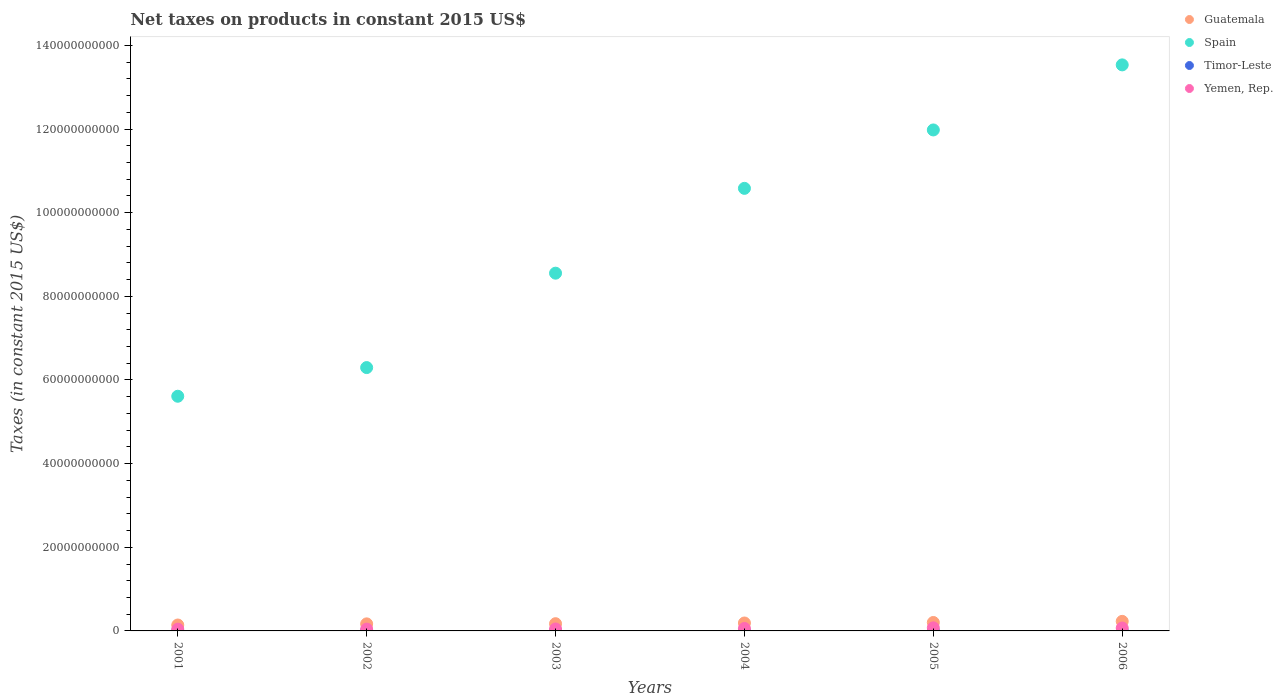How many different coloured dotlines are there?
Offer a very short reply. 4. Is the number of dotlines equal to the number of legend labels?
Keep it short and to the point. No. What is the net taxes on products in Guatemala in 2004?
Your response must be concise. 1.90e+09. Across all years, what is the maximum net taxes on products in Spain?
Your answer should be very brief. 1.35e+11. Across all years, what is the minimum net taxes on products in Spain?
Offer a terse response. 5.61e+1. In which year was the net taxes on products in Timor-Leste maximum?
Offer a very short reply. 2004. What is the total net taxes on products in Guatemala in the graph?
Give a very brief answer. 1.10e+1. What is the difference between the net taxes on products in Yemen, Rep. in 2001 and that in 2003?
Offer a terse response. -4.15e+07. What is the difference between the net taxes on products in Timor-Leste in 2004 and the net taxes on products in Spain in 2002?
Ensure brevity in your answer.  -6.30e+1. What is the average net taxes on products in Spain per year?
Your response must be concise. 9.43e+1. In the year 2005, what is the difference between the net taxes on products in Spain and net taxes on products in Timor-Leste?
Keep it short and to the point. 1.20e+11. In how many years, is the net taxes on products in Spain greater than 92000000000 US$?
Your answer should be compact. 3. What is the ratio of the net taxes on products in Guatemala in 2001 to that in 2002?
Offer a terse response. 0.84. Is the net taxes on products in Yemen, Rep. in 2003 less than that in 2006?
Provide a succinct answer. Yes. Is the difference between the net taxes on products in Spain in 2001 and 2003 greater than the difference between the net taxes on products in Timor-Leste in 2001 and 2003?
Offer a very short reply. No. What is the difference between the highest and the second highest net taxes on products in Spain?
Your response must be concise. 1.56e+1. What is the difference between the highest and the lowest net taxes on products in Yemen, Rep.?
Provide a short and direct response. 3.12e+08. In how many years, is the net taxes on products in Spain greater than the average net taxes on products in Spain taken over all years?
Provide a short and direct response. 3. Is the sum of the net taxes on products in Yemen, Rep. in 2001 and 2004 greater than the maximum net taxes on products in Timor-Leste across all years?
Provide a succinct answer. Yes. Is it the case that in every year, the sum of the net taxes on products in Guatemala and net taxes on products in Timor-Leste  is greater than the sum of net taxes on products in Yemen, Rep. and net taxes on products in Spain?
Keep it short and to the point. Yes. What is the difference between two consecutive major ticks on the Y-axis?
Your response must be concise. 2.00e+1. Are the values on the major ticks of Y-axis written in scientific E-notation?
Give a very brief answer. No. Does the graph contain any zero values?
Provide a short and direct response. Yes. Does the graph contain grids?
Make the answer very short. No. Where does the legend appear in the graph?
Give a very brief answer. Top right. How many legend labels are there?
Provide a short and direct response. 4. What is the title of the graph?
Your answer should be compact. Net taxes on products in constant 2015 US$. Does "Euro area" appear as one of the legend labels in the graph?
Your response must be concise. No. What is the label or title of the Y-axis?
Provide a short and direct response. Taxes (in constant 2015 US$). What is the Taxes (in constant 2015 US$) of Guatemala in 2001?
Ensure brevity in your answer.  1.41e+09. What is the Taxes (in constant 2015 US$) of Spain in 2001?
Make the answer very short. 5.61e+1. What is the Taxes (in constant 2015 US$) in Timor-Leste in 2001?
Keep it short and to the point. 8.00e+06. What is the Taxes (in constant 2015 US$) in Yemen, Rep. in 2001?
Keep it short and to the point. 4.23e+08. What is the Taxes (in constant 2015 US$) of Guatemala in 2002?
Ensure brevity in your answer.  1.69e+09. What is the Taxes (in constant 2015 US$) of Spain in 2002?
Offer a very short reply. 6.30e+1. What is the Taxes (in constant 2015 US$) of Yemen, Rep. in 2002?
Offer a very short reply. 4.32e+08. What is the Taxes (in constant 2015 US$) of Guatemala in 2003?
Offer a terse response. 1.73e+09. What is the Taxes (in constant 2015 US$) in Spain in 2003?
Provide a short and direct response. 8.55e+1. What is the Taxes (in constant 2015 US$) of Timor-Leste in 2003?
Keep it short and to the point. 1.50e+07. What is the Taxes (in constant 2015 US$) in Yemen, Rep. in 2003?
Ensure brevity in your answer.  4.64e+08. What is the Taxes (in constant 2015 US$) in Guatemala in 2004?
Provide a succinct answer. 1.90e+09. What is the Taxes (in constant 2015 US$) of Spain in 2004?
Your response must be concise. 1.06e+11. What is the Taxes (in constant 2015 US$) of Timor-Leste in 2004?
Offer a terse response. 1.60e+07. What is the Taxes (in constant 2015 US$) in Yemen, Rep. in 2004?
Provide a short and direct response. 5.87e+08. What is the Taxes (in constant 2015 US$) in Guatemala in 2005?
Provide a short and direct response. 2.02e+09. What is the Taxes (in constant 2015 US$) in Spain in 2005?
Keep it short and to the point. 1.20e+11. What is the Taxes (in constant 2015 US$) of Timor-Leste in 2005?
Provide a succinct answer. 1.20e+07. What is the Taxes (in constant 2015 US$) in Yemen, Rep. in 2005?
Your answer should be compact. 7.35e+08. What is the Taxes (in constant 2015 US$) of Guatemala in 2006?
Make the answer very short. 2.28e+09. What is the Taxes (in constant 2015 US$) of Spain in 2006?
Provide a succinct answer. 1.35e+11. What is the Taxes (in constant 2015 US$) of Timor-Leste in 2006?
Give a very brief answer. 0. What is the Taxes (in constant 2015 US$) of Yemen, Rep. in 2006?
Make the answer very short. 6.95e+08. Across all years, what is the maximum Taxes (in constant 2015 US$) of Guatemala?
Provide a short and direct response. 2.28e+09. Across all years, what is the maximum Taxes (in constant 2015 US$) of Spain?
Keep it short and to the point. 1.35e+11. Across all years, what is the maximum Taxes (in constant 2015 US$) in Timor-Leste?
Offer a terse response. 1.60e+07. Across all years, what is the maximum Taxes (in constant 2015 US$) in Yemen, Rep.?
Provide a succinct answer. 7.35e+08. Across all years, what is the minimum Taxes (in constant 2015 US$) in Guatemala?
Your response must be concise. 1.41e+09. Across all years, what is the minimum Taxes (in constant 2015 US$) of Spain?
Provide a short and direct response. 5.61e+1. Across all years, what is the minimum Taxes (in constant 2015 US$) in Timor-Leste?
Your response must be concise. 0. Across all years, what is the minimum Taxes (in constant 2015 US$) in Yemen, Rep.?
Provide a short and direct response. 4.23e+08. What is the total Taxes (in constant 2015 US$) in Guatemala in the graph?
Ensure brevity in your answer.  1.10e+1. What is the total Taxes (in constant 2015 US$) of Spain in the graph?
Provide a short and direct response. 5.66e+11. What is the total Taxes (in constant 2015 US$) in Timor-Leste in the graph?
Give a very brief answer. 6.30e+07. What is the total Taxes (in constant 2015 US$) of Yemen, Rep. in the graph?
Offer a very short reply. 3.34e+09. What is the difference between the Taxes (in constant 2015 US$) in Guatemala in 2001 and that in 2002?
Your answer should be compact. -2.72e+08. What is the difference between the Taxes (in constant 2015 US$) of Spain in 2001 and that in 2002?
Provide a succinct answer. -6.86e+09. What is the difference between the Taxes (in constant 2015 US$) of Yemen, Rep. in 2001 and that in 2002?
Ensure brevity in your answer.  -9.52e+06. What is the difference between the Taxes (in constant 2015 US$) in Guatemala in 2001 and that in 2003?
Make the answer very short. -3.14e+08. What is the difference between the Taxes (in constant 2015 US$) of Spain in 2001 and that in 2003?
Offer a very short reply. -2.94e+1. What is the difference between the Taxes (in constant 2015 US$) of Timor-Leste in 2001 and that in 2003?
Provide a succinct answer. -7.00e+06. What is the difference between the Taxes (in constant 2015 US$) of Yemen, Rep. in 2001 and that in 2003?
Provide a succinct answer. -4.15e+07. What is the difference between the Taxes (in constant 2015 US$) in Guatemala in 2001 and that in 2004?
Your response must be concise. -4.82e+08. What is the difference between the Taxes (in constant 2015 US$) of Spain in 2001 and that in 2004?
Offer a terse response. -4.97e+1. What is the difference between the Taxes (in constant 2015 US$) of Timor-Leste in 2001 and that in 2004?
Your answer should be compact. -8.00e+06. What is the difference between the Taxes (in constant 2015 US$) in Yemen, Rep. in 2001 and that in 2004?
Make the answer very short. -1.64e+08. What is the difference between the Taxes (in constant 2015 US$) in Guatemala in 2001 and that in 2005?
Offer a terse response. -6.03e+08. What is the difference between the Taxes (in constant 2015 US$) in Spain in 2001 and that in 2005?
Your answer should be very brief. -6.37e+1. What is the difference between the Taxes (in constant 2015 US$) of Timor-Leste in 2001 and that in 2005?
Provide a short and direct response. -4.00e+06. What is the difference between the Taxes (in constant 2015 US$) of Yemen, Rep. in 2001 and that in 2005?
Ensure brevity in your answer.  -3.12e+08. What is the difference between the Taxes (in constant 2015 US$) of Guatemala in 2001 and that in 2006?
Your response must be concise. -8.70e+08. What is the difference between the Taxes (in constant 2015 US$) of Spain in 2001 and that in 2006?
Your answer should be compact. -7.92e+1. What is the difference between the Taxes (in constant 2015 US$) of Yemen, Rep. in 2001 and that in 2006?
Offer a very short reply. -2.72e+08. What is the difference between the Taxes (in constant 2015 US$) in Guatemala in 2002 and that in 2003?
Your response must be concise. -4.17e+07. What is the difference between the Taxes (in constant 2015 US$) in Spain in 2002 and that in 2003?
Provide a short and direct response. -2.26e+1. What is the difference between the Taxes (in constant 2015 US$) of Timor-Leste in 2002 and that in 2003?
Your answer should be very brief. -3.00e+06. What is the difference between the Taxes (in constant 2015 US$) of Yemen, Rep. in 2002 and that in 2003?
Give a very brief answer. -3.20e+07. What is the difference between the Taxes (in constant 2015 US$) of Guatemala in 2002 and that in 2004?
Keep it short and to the point. -2.09e+08. What is the difference between the Taxes (in constant 2015 US$) of Spain in 2002 and that in 2004?
Provide a short and direct response. -4.29e+1. What is the difference between the Taxes (in constant 2015 US$) of Yemen, Rep. in 2002 and that in 2004?
Provide a succinct answer. -1.54e+08. What is the difference between the Taxes (in constant 2015 US$) in Guatemala in 2002 and that in 2005?
Offer a terse response. -3.30e+08. What is the difference between the Taxes (in constant 2015 US$) of Spain in 2002 and that in 2005?
Provide a short and direct response. -5.68e+1. What is the difference between the Taxes (in constant 2015 US$) of Yemen, Rep. in 2002 and that in 2005?
Offer a very short reply. -3.02e+08. What is the difference between the Taxes (in constant 2015 US$) of Guatemala in 2002 and that in 2006?
Your answer should be compact. -5.98e+08. What is the difference between the Taxes (in constant 2015 US$) of Spain in 2002 and that in 2006?
Your answer should be very brief. -7.24e+1. What is the difference between the Taxes (in constant 2015 US$) in Yemen, Rep. in 2002 and that in 2006?
Offer a very short reply. -2.63e+08. What is the difference between the Taxes (in constant 2015 US$) of Guatemala in 2003 and that in 2004?
Ensure brevity in your answer.  -1.68e+08. What is the difference between the Taxes (in constant 2015 US$) of Spain in 2003 and that in 2004?
Offer a terse response. -2.03e+1. What is the difference between the Taxes (in constant 2015 US$) in Timor-Leste in 2003 and that in 2004?
Make the answer very short. -1.00e+06. What is the difference between the Taxes (in constant 2015 US$) of Yemen, Rep. in 2003 and that in 2004?
Your answer should be compact. -1.22e+08. What is the difference between the Taxes (in constant 2015 US$) of Guatemala in 2003 and that in 2005?
Provide a succinct answer. -2.89e+08. What is the difference between the Taxes (in constant 2015 US$) in Spain in 2003 and that in 2005?
Your answer should be very brief. -3.42e+1. What is the difference between the Taxes (in constant 2015 US$) of Timor-Leste in 2003 and that in 2005?
Make the answer very short. 3.00e+06. What is the difference between the Taxes (in constant 2015 US$) in Yemen, Rep. in 2003 and that in 2005?
Provide a succinct answer. -2.70e+08. What is the difference between the Taxes (in constant 2015 US$) of Guatemala in 2003 and that in 2006?
Your answer should be compact. -5.57e+08. What is the difference between the Taxes (in constant 2015 US$) of Spain in 2003 and that in 2006?
Offer a very short reply. -4.98e+1. What is the difference between the Taxes (in constant 2015 US$) of Yemen, Rep. in 2003 and that in 2006?
Make the answer very short. -2.31e+08. What is the difference between the Taxes (in constant 2015 US$) in Guatemala in 2004 and that in 2005?
Offer a very short reply. -1.21e+08. What is the difference between the Taxes (in constant 2015 US$) in Spain in 2004 and that in 2005?
Ensure brevity in your answer.  -1.40e+1. What is the difference between the Taxes (in constant 2015 US$) of Yemen, Rep. in 2004 and that in 2005?
Offer a terse response. -1.48e+08. What is the difference between the Taxes (in constant 2015 US$) of Guatemala in 2004 and that in 2006?
Keep it short and to the point. -3.89e+08. What is the difference between the Taxes (in constant 2015 US$) of Spain in 2004 and that in 2006?
Offer a very short reply. -2.95e+1. What is the difference between the Taxes (in constant 2015 US$) of Yemen, Rep. in 2004 and that in 2006?
Ensure brevity in your answer.  -1.09e+08. What is the difference between the Taxes (in constant 2015 US$) of Guatemala in 2005 and that in 2006?
Make the answer very short. -2.68e+08. What is the difference between the Taxes (in constant 2015 US$) of Spain in 2005 and that in 2006?
Give a very brief answer. -1.56e+1. What is the difference between the Taxes (in constant 2015 US$) of Yemen, Rep. in 2005 and that in 2006?
Your answer should be very brief. 3.95e+07. What is the difference between the Taxes (in constant 2015 US$) in Guatemala in 2001 and the Taxes (in constant 2015 US$) in Spain in 2002?
Your answer should be very brief. -6.16e+1. What is the difference between the Taxes (in constant 2015 US$) in Guatemala in 2001 and the Taxes (in constant 2015 US$) in Timor-Leste in 2002?
Make the answer very short. 1.40e+09. What is the difference between the Taxes (in constant 2015 US$) of Guatemala in 2001 and the Taxes (in constant 2015 US$) of Yemen, Rep. in 2002?
Make the answer very short. 9.81e+08. What is the difference between the Taxes (in constant 2015 US$) in Spain in 2001 and the Taxes (in constant 2015 US$) in Timor-Leste in 2002?
Provide a short and direct response. 5.61e+1. What is the difference between the Taxes (in constant 2015 US$) in Spain in 2001 and the Taxes (in constant 2015 US$) in Yemen, Rep. in 2002?
Give a very brief answer. 5.57e+1. What is the difference between the Taxes (in constant 2015 US$) of Timor-Leste in 2001 and the Taxes (in constant 2015 US$) of Yemen, Rep. in 2002?
Keep it short and to the point. -4.24e+08. What is the difference between the Taxes (in constant 2015 US$) of Guatemala in 2001 and the Taxes (in constant 2015 US$) of Spain in 2003?
Make the answer very short. -8.41e+1. What is the difference between the Taxes (in constant 2015 US$) of Guatemala in 2001 and the Taxes (in constant 2015 US$) of Timor-Leste in 2003?
Ensure brevity in your answer.  1.40e+09. What is the difference between the Taxes (in constant 2015 US$) in Guatemala in 2001 and the Taxes (in constant 2015 US$) in Yemen, Rep. in 2003?
Your answer should be compact. 9.49e+08. What is the difference between the Taxes (in constant 2015 US$) in Spain in 2001 and the Taxes (in constant 2015 US$) in Timor-Leste in 2003?
Provide a succinct answer. 5.61e+1. What is the difference between the Taxes (in constant 2015 US$) of Spain in 2001 and the Taxes (in constant 2015 US$) of Yemen, Rep. in 2003?
Ensure brevity in your answer.  5.56e+1. What is the difference between the Taxes (in constant 2015 US$) in Timor-Leste in 2001 and the Taxes (in constant 2015 US$) in Yemen, Rep. in 2003?
Offer a very short reply. -4.56e+08. What is the difference between the Taxes (in constant 2015 US$) in Guatemala in 2001 and the Taxes (in constant 2015 US$) in Spain in 2004?
Offer a very short reply. -1.04e+11. What is the difference between the Taxes (in constant 2015 US$) in Guatemala in 2001 and the Taxes (in constant 2015 US$) in Timor-Leste in 2004?
Make the answer very short. 1.40e+09. What is the difference between the Taxes (in constant 2015 US$) of Guatemala in 2001 and the Taxes (in constant 2015 US$) of Yemen, Rep. in 2004?
Keep it short and to the point. 8.27e+08. What is the difference between the Taxes (in constant 2015 US$) of Spain in 2001 and the Taxes (in constant 2015 US$) of Timor-Leste in 2004?
Ensure brevity in your answer.  5.61e+1. What is the difference between the Taxes (in constant 2015 US$) of Spain in 2001 and the Taxes (in constant 2015 US$) of Yemen, Rep. in 2004?
Make the answer very short. 5.55e+1. What is the difference between the Taxes (in constant 2015 US$) in Timor-Leste in 2001 and the Taxes (in constant 2015 US$) in Yemen, Rep. in 2004?
Provide a succinct answer. -5.79e+08. What is the difference between the Taxes (in constant 2015 US$) in Guatemala in 2001 and the Taxes (in constant 2015 US$) in Spain in 2005?
Offer a very short reply. -1.18e+11. What is the difference between the Taxes (in constant 2015 US$) in Guatemala in 2001 and the Taxes (in constant 2015 US$) in Timor-Leste in 2005?
Your response must be concise. 1.40e+09. What is the difference between the Taxes (in constant 2015 US$) in Guatemala in 2001 and the Taxes (in constant 2015 US$) in Yemen, Rep. in 2005?
Provide a succinct answer. 6.79e+08. What is the difference between the Taxes (in constant 2015 US$) in Spain in 2001 and the Taxes (in constant 2015 US$) in Timor-Leste in 2005?
Your answer should be very brief. 5.61e+1. What is the difference between the Taxes (in constant 2015 US$) in Spain in 2001 and the Taxes (in constant 2015 US$) in Yemen, Rep. in 2005?
Give a very brief answer. 5.54e+1. What is the difference between the Taxes (in constant 2015 US$) of Timor-Leste in 2001 and the Taxes (in constant 2015 US$) of Yemen, Rep. in 2005?
Give a very brief answer. -7.27e+08. What is the difference between the Taxes (in constant 2015 US$) in Guatemala in 2001 and the Taxes (in constant 2015 US$) in Spain in 2006?
Offer a terse response. -1.34e+11. What is the difference between the Taxes (in constant 2015 US$) of Guatemala in 2001 and the Taxes (in constant 2015 US$) of Yemen, Rep. in 2006?
Keep it short and to the point. 7.18e+08. What is the difference between the Taxes (in constant 2015 US$) in Spain in 2001 and the Taxes (in constant 2015 US$) in Yemen, Rep. in 2006?
Give a very brief answer. 5.54e+1. What is the difference between the Taxes (in constant 2015 US$) in Timor-Leste in 2001 and the Taxes (in constant 2015 US$) in Yemen, Rep. in 2006?
Make the answer very short. -6.87e+08. What is the difference between the Taxes (in constant 2015 US$) of Guatemala in 2002 and the Taxes (in constant 2015 US$) of Spain in 2003?
Keep it short and to the point. -8.39e+1. What is the difference between the Taxes (in constant 2015 US$) in Guatemala in 2002 and the Taxes (in constant 2015 US$) in Timor-Leste in 2003?
Your response must be concise. 1.67e+09. What is the difference between the Taxes (in constant 2015 US$) of Guatemala in 2002 and the Taxes (in constant 2015 US$) of Yemen, Rep. in 2003?
Provide a succinct answer. 1.22e+09. What is the difference between the Taxes (in constant 2015 US$) in Spain in 2002 and the Taxes (in constant 2015 US$) in Timor-Leste in 2003?
Ensure brevity in your answer.  6.30e+1. What is the difference between the Taxes (in constant 2015 US$) in Spain in 2002 and the Taxes (in constant 2015 US$) in Yemen, Rep. in 2003?
Make the answer very short. 6.25e+1. What is the difference between the Taxes (in constant 2015 US$) in Timor-Leste in 2002 and the Taxes (in constant 2015 US$) in Yemen, Rep. in 2003?
Give a very brief answer. -4.52e+08. What is the difference between the Taxes (in constant 2015 US$) in Guatemala in 2002 and the Taxes (in constant 2015 US$) in Spain in 2004?
Provide a succinct answer. -1.04e+11. What is the difference between the Taxes (in constant 2015 US$) in Guatemala in 2002 and the Taxes (in constant 2015 US$) in Timor-Leste in 2004?
Make the answer very short. 1.67e+09. What is the difference between the Taxes (in constant 2015 US$) of Guatemala in 2002 and the Taxes (in constant 2015 US$) of Yemen, Rep. in 2004?
Give a very brief answer. 1.10e+09. What is the difference between the Taxes (in constant 2015 US$) in Spain in 2002 and the Taxes (in constant 2015 US$) in Timor-Leste in 2004?
Ensure brevity in your answer.  6.30e+1. What is the difference between the Taxes (in constant 2015 US$) in Spain in 2002 and the Taxes (in constant 2015 US$) in Yemen, Rep. in 2004?
Your response must be concise. 6.24e+1. What is the difference between the Taxes (in constant 2015 US$) of Timor-Leste in 2002 and the Taxes (in constant 2015 US$) of Yemen, Rep. in 2004?
Provide a succinct answer. -5.75e+08. What is the difference between the Taxes (in constant 2015 US$) of Guatemala in 2002 and the Taxes (in constant 2015 US$) of Spain in 2005?
Offer a terse response. -1.18e+11. What is the difference between the Taxes (in constant 2015 US$) in Guatemala in 2002 and the Taxes (in constant 2015 US$) in Timor-Leste in 2005?
Your answer should be very brief. 1.67e+09. What is the difference between the Taxes (in constant 2015 US$) of Guatemala in 2002 and the Taxes (in constant 2015 US$) of Yemen, Rep. in 2005?
Make the answer very short. 9.51e+08. What is the difference between the Taxes (in constant 2015 US$) of Spain in 2002 and the Taxes (in constant 2015 US$) of Timor-Leste in 2005?
Provide a short and direct response. 6.30e+1. What is the difference between the Taxes (in constant 2015 US$) of Spain in 2002 and the Taxes (in constant 2015 US$) of Yemen, Rep. in 2005?
Your answer should be compact. 6.22e+1. What is the difference between the Taxes (in constant 2015 US$) in Timor-Leste in 2002 and the Taxes (in constant 2015 US$) in Yemen, Rep. in 2005?
Provide a succinct answer. -7.23e+08. What is the difference between the Taxes (in constant 2015 US$) in Guatemala in 2002 and the Taxes (in constant 2015 US$) in Spain in 2006?
Make the answer very short. -1.34e+11. What is the difference between the Taxes (in constant 2015 US$) in Guatemala in 2002 and the Taxes (in constant 2015 US$) in Yemen, Rep. in 2006?
Make the answer very short. 9.90e+08. What is the difference between the Taxes (in constant 2015 US$) of Spain in 2002 and the Taxes (in constant 2015 US$) of Yemen, Rep. in 2006?
Provide a short and direct response. 6.23e+1. What is the difference between the Taxes (in constant 2015 US$) of Timor-Leste in 2002 and the Taxes (in constant 2015 US$) of Yemen, Rep. in 2006?
Keep it short and to the point. -6.83e+08. What is the difference between the Taxes (in constant 2015 US$) of Guatemala in 2003 and the Taxes (in constant 2015 US$) of Spain in 2004?
Give a very brief answer. -1.04e+11. What is the difference between the Taxes (in constant 2015 US$) in Guatemala in 2003 and the Taxes (in constant 2015 US$) in Timor-Leste in 2004?
Provide a succinct answer. 1.71e+09. What is the difference between the Taxes (in constant 2015 US$) in Guatemala in 2003 and the Taxes (in constant 2015 US$) in Yemen, Rep. in 2004?
Make the answer very short. 1.14e+09. What is the difference between the Taxes (in constant 2015 US$) in Spain in 2003 and the Taxes (in constant 2015 US$) in Timor-Leste in 2004?
Make the answer very short. 8.55e+1. What is the difference between the Taxes (in constant 2015 US$) in Spain in 2003 and the Taxes (in constant 2015 US$) in Yemen, Rep. in 2004?
Give a very brief answer. 8.50e+1. What is the difference between the Taxes (in constant 2015 US$) in Timor-Leste in 2003 and the Taxes (in constant 2015 US$) in Yemen, Rep. in 2004?
Your answer should be compact. -5.72e+08. What is the difference between the Taxes (in constant 2015 US$) in Guatemala in 2003 and the Taxes (in constant 2015 US$) in Spain in 2005?
Provide a succinct answer. -1.18e+11. What is the difference between the Taxes (in constant 2015 US$) in Guatemala in 2003 and the Taxes (in constant 2015 US$) in Timor-Leste in 2005?
Offer a terse response. 1.72e+09. What is the difference between the Taxes (in constant 2015 US$) in Guatemala in 2003 and the Taxes (in constant 2015 US$) in Yemen, Rep. in 2005?
Your response must be concise. 9.93e+08. What is the difference between the Taxes (in constant 2015 US$) in Spain in 2003 and the Taxes (in constant 2015 US$) in Timor-Leste in 2005?
Offer a very short reply. 8.55e+1. What is the difference between the Taxes (in constant 2015 US$) in Spain in 2003 and the Taxes (in constant 2015 US$) in Yemen, Rep. in 2005?
Offer a very short reply. 8.48e+1. What is the difference between the Taxes (in constant 2015 US$) in Timor-Leste in 2003 and the Taxes (in constant 2015 US$) in Yemen, Rep. in 2005?
Offer a very short reply. -7.20e+08. What is the difference between the Taxes (in constant 2015 US$) of Guatemala in 2003 and the Taxes (in constant 2015 US$) of Spain in 2006?
Provide a short and direct response. -1.34e+11. What is the difference between the Taxes (in constant 2015 US$) in Guatemala in 2003 and the Taxes (in constant 2015 US$) in Yemen, Rep. in 2006?
Make the answer very short. 1.03e+09. What is the difference between the Taxes (in constant 2015 US$) of Spain in 2003 and the Taxes (in constant 2015 US$) of Yemen, Rep. in 2006?
Your response must be concise. 8.48e+1. What is the difference between the Taxes (in constant 2015 US$) in Timor-Leste in 2003 and the Taxes (in constant 2015 US$) in Yemen, Rep. in 2006?
Make the answer very short. -6.80e+08. What is the difference between the Taxes (in constant 2015 US$) of Guatemala in 2004 and the Taxes (in constant 2015 US$) of Spain in 2005?
Provide a succinct answer. -1.18e+11. What is the difference between the Taxes (in constant 2015 US$) of Guatemala in 2004 and the Taxes (in constant 2015 US$) of Timor-Leste in 2005?
Give a very brief answer. 1.88e+09. What is the difference between the Taxes (in constant 2015 US$) in Guatemala in 2004 and the Taxes (in constant 2015 US$) in Yemen, Rep. in 2005?
Keep it short and to the point. 1.16e+09. What is the difference between the Taxes (in constant 2015 US$) in Spain in 2004 and the Taxes (in constant 2015 US$) in Timor-Leste in 2005?
Make the answer very short. 1.06e+11. What is the difference between the Taxes (in constant 2015 US$) of Spain in 2004 and the Taxes (in constant 2015 US$) of Yemen, Rep. in 2005?
Your answer should be compact. 1.05e+11. What is the difference between the Taxes (in constant 2015 US$) in Timor-Leste in 2004 and the Taxes (in constant 2015 US$) in Yemen, Rep. in 2005?
Give a very brief answer. -7.19e+08. What is the difference between the Taxes (in constant 2015 US$) of Guatemala in 2004 and the Taxes (in constant 2015 US$) of Spain in 2006?
Give a very brief answer. -1.33e+11. What is the difference between the Taxes (in constant 2015 US$) in Guatemala in 2004 and the Taxes (in constant 2015 US$) in Yemen, Rep. in 2006?
Ensure brevity in your answer.  1.20e+09. What is the difference between the Taxes (in constant 2015 US$) of Spain in 2004 and the Taxes (in constant 2015 US$) of Yemen, Rep. in 2006?
Offer a very short reply. 1.05e+11. What is the difference between the Taxes (in constant 2015 US$) of Timor-Leste in 2004 and the Taxes (in constant 2015 US$) of Yemen, Rep. in 2006?
Provide a short and direct response. -6.79e+08. What is the difference between the Taxes (in constant 2015 US$) of Guatemala in 2005 and the Taxes (in constant 2015 US$) of Spain in 2006?
Offer a very short reply. -1.33e+11. What is the difference between the Taxes (in constant 2015 US$) in Guatemala in 2005 and the Taxes (in constant 2015 US$) in Yemen, Rep. in 2006?
Give a very brief answer. 1.32e+09. What is the difference between the Taxes (in constant 2015 US$) in Spain in 2005 and the Taxes (in constant 2015 US$) in Yemen, Rep. in 2006?
Offer a very short reply. 1.19e+11. What is the difference between the Taxes (in constant 2015 US$) of Timor-Leste in 2005 and the Taxes (in constant 2015 US$) of Yemen, Rep. in 2006?
Offer a very short reply. -6.83e+08. What is the average Taxes (in constant 2015 US$) of Guatemala per year?
Your answer should be very brief. 1.84e+09. What is the average Taxes (in constant 2015 US$) in Spain per year?
Make the answer very short. 9.43e+1. What is the average Taxes (in constant 2015 US$) in Timor-Leste per year?
Keep it short and to the point. 1.05e+07. What is the average Taxes (in constant 2015 US$) in Yemen, Rep. per year?
Your answer should be very brief. 5.56e+08. In the year 2001, what is the difference between the Taxes (in constant 2015 US$) of Guatemala and Taxes (in constant 2015 US$) of Spain?
Provide a short and direct response. -5.47e+1. In the year 2001, what is the difference between the Taxes (in constant 2015 US$) in Guatemala and Taxes (in constant 2015 US$) in Timor-Leste?
Offer a very short reply. 1.41e+09. In the year 2001, what is the difference between the Taxes (in constant 2015 US$) in Guatemala and Taxes (in constant 2015 US$) in Yemen, Rep.?
Make the answer very short. 9.91e+08. In the year 2001, what is the difference between the Taxes (in constant 2015 US$) of Spain and Taxes (in constant 2015 US$) of Timor-Leste?
Give a very brief answer. 5.61e+1. In the year 2001, what is the difference between the Taxes (in constant 2015 US$) in Spain and Taxes (in constant 2015 US$) in Yemen, Rep.?
Provide a succinct answer. 5.57e+1. In the year 2001, what is the difference between the Taxes (in constant 2015 US$) of Timor-Leste and Taxes (in constant 2015 US$) of Yemen, Rep.?
Your answer should be compact. -4.15e+08. In the year 2002, what is the difference between the Taxes (in constant 2015 US$) in Guatemala and Taxes (in constant 2015 US$) in Spain?
Offer a terse response. -6.13e+1. In the year 2002, what is the difference between the Taxes (in constant 2015 US$) of Guatemala and Taxes (in constant 2015 US$) of Timor-Leste?
Make the answer very short. 1.67e+09. In the year 2002, what is the difference between the Taxes (in constant 2015 US$) of Guatemala and Taxes (in constant 2015 US$) of Yemen, Rep.?
Keep it short and to the point. 1.25e+09. In the year 2002, what is the difference between the Taxes (in constant 2015 US$) in Spain and Taxes (in constant 2015 US$) in Timor-Leste?
Your answer should be very brief. 6.30e+1. In the year 2002, what is the difference between the Taxes (in constant 2015 US$) of Spain and Taxes (in constant 2015 US$) of Yemen, Rep.?
Provide a succinct answer. 6.25e+1. In the year 2002, what is the difference between the Taxes (in constant 2015 US$) of Timor-Leste and Taxes (in constant 2015 US$) of Yemen, Rep.?
Offer a terse response. -4.20e+08. In the year 2003, what is the difference between the Taxes (in constant 2015 US$) of Guatemala and Taxes (in constant 2015 US$) of Spain?
Provide a succinct answer. -8.38e+1. In the year 2003, what is the difference between the Taxes (in constant 2015 US$) of Guatemala and Taxes (in constant 2015 US$) of Timor-Leste?
Keep it short and to the point. 1.71e+09. In the year 2003, what is the difference between the Taxes (in constant 2015 US$) of Guatemala and Taxes (in constant 2015 US$) of Yemen, Rep.?
Provide a short and direct response. 1.26e+09. In the year 2003, what is the difference between the Taxes (in constant 2015 US$) in Spain and Taxes (in constant 2015 US$) in Timor-Leste?
Your answer should be very brief. 8.55e+1. In the year 2003, what is the difference between the Taxes (in constant 2015 US$) of Spain and Taxes (in constant 2015 US$) of Yemen, Rep.?
Your response must be concise. 8.51e+1. In the year 2003, what is the difference between the Taxes (in constant 2015 US$) in Timor-Leste and Taxes (in constant 2015 US$) in Yemen, Rep.?
Offer a very short reply. -4.49e+08. In the year 2004, what is the difference between the Taxes (in constant 2015 US$) in Guatemala and Taxes (in constant 2015 US$) in Spain?
Give a very brief answer. -1.04e+11. In the year 2004, what is the difference between the Taxes (in constant 2015 US$) of Guatemala and Taxes (in constant 2015 US$) of Timor-Leste?
Your answer should be compact. 1.88e+09. In the year 2004, what is the difference between the Taxes (in constant 2015 US$) in Guatemala and Taxes (in constant 2015 US$) in Yemen, Rep.?
Offer a terse response. 1.31e+09. In the year 2004, what is the difference between the Taxes (in constant 2015 US$) in Spain and Taxes (in constant 2015 US$) in Timor-Leste?
Make the answer very short. 1.06e+11. In the year 2004, what is the difference between the Taxes (in constant 2015 US$) of Spain and Taxes (in constant 2015 US$) of Yemen, Rep.?
Offer a very short reply. 1.05e+11. In the year 2004, what is the difference between the Taxes (in constant 2015 US$) of Timor-Leste and Taxes (in constant 2015 US$) of Yemen, Rep.?
Provide a succinct answer. -5.71e+08. In the year 2005, what is the difference between the Taxes (in constant 2015 US$) in Guatemala and Taxes (in constant 2015 US$) in Spain?
Give a very brief answer. -1.18e+11. In the year 2005, what is the difference between the Taxes (in constant 2015 US$) of Guatemala and Taxes (in constant 2015 US$) of Timor-Leste?
Ensure brevity in your answer.  2.00e+09. In the year 2005, what is the difference between the Taxes (in constant 2015 US$) of Guatemala and Taxes (in constant 2015 US$) of Yemen, Rep.?
Give a very brief answer. 1.28e+09. In the year 2005, what is the difference between the Taxes (in constant 2015 US$) of Spain and Taxes (in constant 2015 US$) of Timor-Leste?
Offer a very short reply. 1.20e+11. In the year 2005, what is the difference between the Taxes (in constant 2015 US$) of Spain and Taxes (in constant 2015 US$) of Yemen, Rep.?
Give a very brief answer. 1.19e+11. In the year 2005, what is the difference between the Taxes (in constant 2015 US$) in Timor-Leste and Taxes (in constant 2015 US$) in Yemen, Rep.?
Ensure brevity in your answer.  -7.23e+08. In the year 2006, what is the difference between the Taxes (in constant 2015 US$) in Guatemala and Taxes (in constant 2015 US$) in Spain?
Ensure brevity in your answer.  -1.33e+11. In the year 2006, what is the difference between the Taxes (in constant 2015 US$) of Guatemala and Taxes (in constant 2015 US$) of Yemen, Rep.?
Provide a succinct answer. 1.59e+09. In the year 2006, what is the difference between the Taxes (in constant 2015 US$) in Spain and Taxes (in constant 2015 US$) in Yemen, Rep.?
Keep it short and to the point. 1.35e+11. What is the ratio of the Taxes (in constant 2015 US$) of Guatemala in 2001 to that in 2002?
Your answer should be compact. 0.84. What is the ratio of the Taxes (in constant 2015 US$) in Spain in 2001 to that in 2002?
Your response must be concise. 0.89. What is the ratio of the Taxes (in constant 2015 US$) in Guatemala in 2001 to that in 2003?
Your answer should be compact. 0.82. What is the ratio of the Taxes (in constant 2015 US$) in Spain in 2001 to that in 2003?
Provide a succinct answer. 0.66. What is the ratio of the Taxes (in constant 2015 US$) in Timor-Leste in 2001 to that in 2003?
Offer a terse response. 0.53. What is the ratio of the Taxes (in constant 2015 US$) in Yemen, Rep. in 2001 to that in 2003?
Your answer should be very brief. 0.91. What is the ratio of the Taxes (in constant 2015 US$) of Guatemala in 2001 to that in 2004?
Provide a succinct answer. 0.75. What is the ratio of the Taxes (in constant 2015 US$) of Spain in 2001 to that in 2004?
Your answer should be very brief. 0.53. What is the ratio of the Taxes (in constant 2015 US$) in Timor-Leste in 2001 to that in 2004?
Offer a very short reply. 0.5. What is the ratio of the Taxes (in constant 2015 US$) of Yemen, Rep. in 2001 to that in 2004?
Provide a short and direct response. 0.72. What is the ratio of the Taxes (in constant 2015 US$) of Guatemala in 2001 to that in 2005?
Your answer should be very brief. 0.7. What is the ratio of the Taxes (in constant 2015 US$) of Spain in 2001 to that in 2005?
Provide a succinct answer. 0.47. What is the ratio of the Taxes (in constant 2015 US$) of Timor-Leste in 2001 to that in 2005?
Give a very brief answer. 0.67. What is the ratio of the Taxes (in constant 2015 US$) in Yemen, Rep. in 2001 to that in 2005?
Keep it short and to the point. 0.58. What is the ratio of the Taxes (in constant 2015 US$) of Guatemala in 2001 to that in 2006?
Your answer should be compact. 0.62. What is the ratio of the Taxes (in constant 2015 US$) of Spain in 2001 to that in 2006?
Your response must be concise. 0.41. What is the ratio of the Taxes (in constant 2015 US$) of Yemen, Rep. in 2001 to that in 2006?
Give a very brief answer. 0.61. What is the ratio of the Taxes (in constant 2015 US$) in Guatemala in 2002 to that in 2003?
Your answer should be very brief. 0.98. What is the ratio of the Taxes (in constant 2015 US$) of Spain in 2002 to that in 2003?
Offer a very short reply. 0.74. What is the ratio of the Taxes (in constant 2015 US$) in Yemen, Rep. in 2002 to that in 2003?
Provide a succinct answer. 0.93. What is the ratio of the Taxes (in constant 2015 US$) in Guatemala in 2002 to that in 2004?
Give a very brief answer. 0.89. What is the ratio of the Taxes (in constant 2015 US$) of Spain in 2002 to that in 2004?
Offer a terse response. 0.59. What is the ratio of the Taxes (in constant 2015 US$) in Timor-Leste in 2002 to that in 2004?
Offer a terse response. 0.75. What is the ratio of the Taxes (in constant 2015 US$) of Yemen, Rep. in 2002 to that in 2004?
Offer a terse response. 0.74. What is the ratio of the Taxes (in constant 2015 US$) of Guatemala in 2002 to that in 2005?
Provide a short and direct response. 0.84. What is the ratio of the Taxes (in constant 2015 US$) in Spain in 2002 to that in 2005?
Keep it short and to the point. 0.53. What is the ratio of the Taxes (in constant 2015 US$) of Yemen, Rep. in 2002 to that in 2005?
Give a very brief answer. 0.59. What is the ratio of the Taxes (in constant 2015 US$) in Guatemala in 2002 to that in 2006?
Provide a short and direct response. 0.74. What is the ratio of the Taxes (in constant 2015 US$) of Spain in 2002 to that in 2006?
Provide a short and direct response. 0.47. What is the ratio of the Taxes (in constant 2015 US$) of Yemen, Rep. in 2002 to that in 2006?
Provide a succinct answer. 0.62. What is the ratio of the Taxes (in constant 2015 US$) of Guatemala in 2003 to that in 2004?
Offer a terse response. 0.91. What is the ratio of the Taxes (in constant 2015 US$) of Spain in 2003 to that in 2004?
Offer a terse response. 0.81. What is the ratio of the Taxes (in constant 2015 US$) of Timor-Leste in 2003 to that in 2004?
Your answer should be compact. 0.94. What is the ratio of the Taxes (in constant 2015 US$) in Yemen, Rep. in 2003 to that in 2004?
Your response must be concise. 0.79. What is the ratio of the Taxes (in constant 2015 US$) of Guatemala in 2003 to that in 2005?
Offer a terse response. 0.86. What is the ratio of the Taxes (in constant 2015 US$) of Spain in 2003 to that in 2005?
Provide a short and direct response. 0.71. What is the ratio of the Taxes (in constant 2015 US$) of Timor-Leste in 2003 to that in 2005?
Your answer should be very brief. 1.25. What is the ratio of the Taxes (in constant 2015 US$) in Yemen, Rep. in 2003 to that in 2005?
Provide a short and direct response. 0.63. What is the ratio of the Taxes (in constant 2015 US$) of Guatemala in 2003 to that in 2006?
Provide a succinct answer. 0.76. What is the ratio of the Taxes (in constant 2015 US$) of Spain in 2003 to that in 2006?
Your response must be concise. 0.63. What is the ratio of the Taxes (in constant 2015 US$) of Yemen, Rep. in 2003 to that in 2006?
Offer a terse response. 0.67. What is the ratio of the Taxes (in constant 2015 US$) in Guatemala in 2004 to that in 2005?
Provide a short and direct response. 0.94. What is the ratio of the Taxes (in constant 2015 US$) of Spain in 2004 to that in 2005?
Your answer should be compact. 0.88. What is the ratio of the Taxes (in constant 2015 US$) of Yemen, Rep. in 2004 to that in 2005?
Ensure brevity in your answer.  0.8. What is the ratio of the Taxes (in constant 2015 US$) in Guatemala in 2004 to that in 2006?
Offer a terse response. 0.83. What is the ratio of the Taxes (in constant 2015 US$) of Spain in 2004 to that in 2006?
Provide a succinct answer. 0.78. What is the ratio of the Taxes (in constant 2015 US$) in Yemen, Rep. in 2004 to that in 2006?
Provide a succinct answer. 0.84. What is the ratio of the Taxes (in constant 2015 US$) in Guatemala in 2005 to that in 2006?
Provide a short and direct response. 0.88. What is the ratio of the Taxes (in constant 2015 US$) in Spain in 2005 to that in 2006?
Your answer should be compact. 0.89. What is the ratio of the Taxes (in constant 2015 US$) of Yemen, Rep. in 2005 to that in 2006?
Your response must be concise. 1.06. What is the difference between the highest and the second highest Taxes (in constant 2015 US$) in Guatemala?
Give a very brief answer. 2.68e+08. What is the difference between the highest and the second highest Taxes (in constant 2015 US$) of Spain?
Give a very brief answer. 1.56e+1. What is the difference between the highest and the second highest Taxes (in constant 2015 US$) in Yemen, Rep.?
Offer a very short reply. 3.95e+07. What is the difference between the highest and the lowest Taxes (in constant 2015 US$) of Guatemala?
Provide a succinct answer. 8.70e+08. What is the difference between the highest and the lowest Taxes (in constant 2015 US$) of Spain?
Your response must be concise. 7.92e+1. What is the difference between the highest and the lowest Taxes (in constant 2015 US$) of Timor-Leste?
Make the answer very short. 1.60e+07. What is the difference between the highest and the lowest Taxes (in constant 2015 US$) in Yemen, Rep.?
Offer a very short reply. 3.12e+08. 